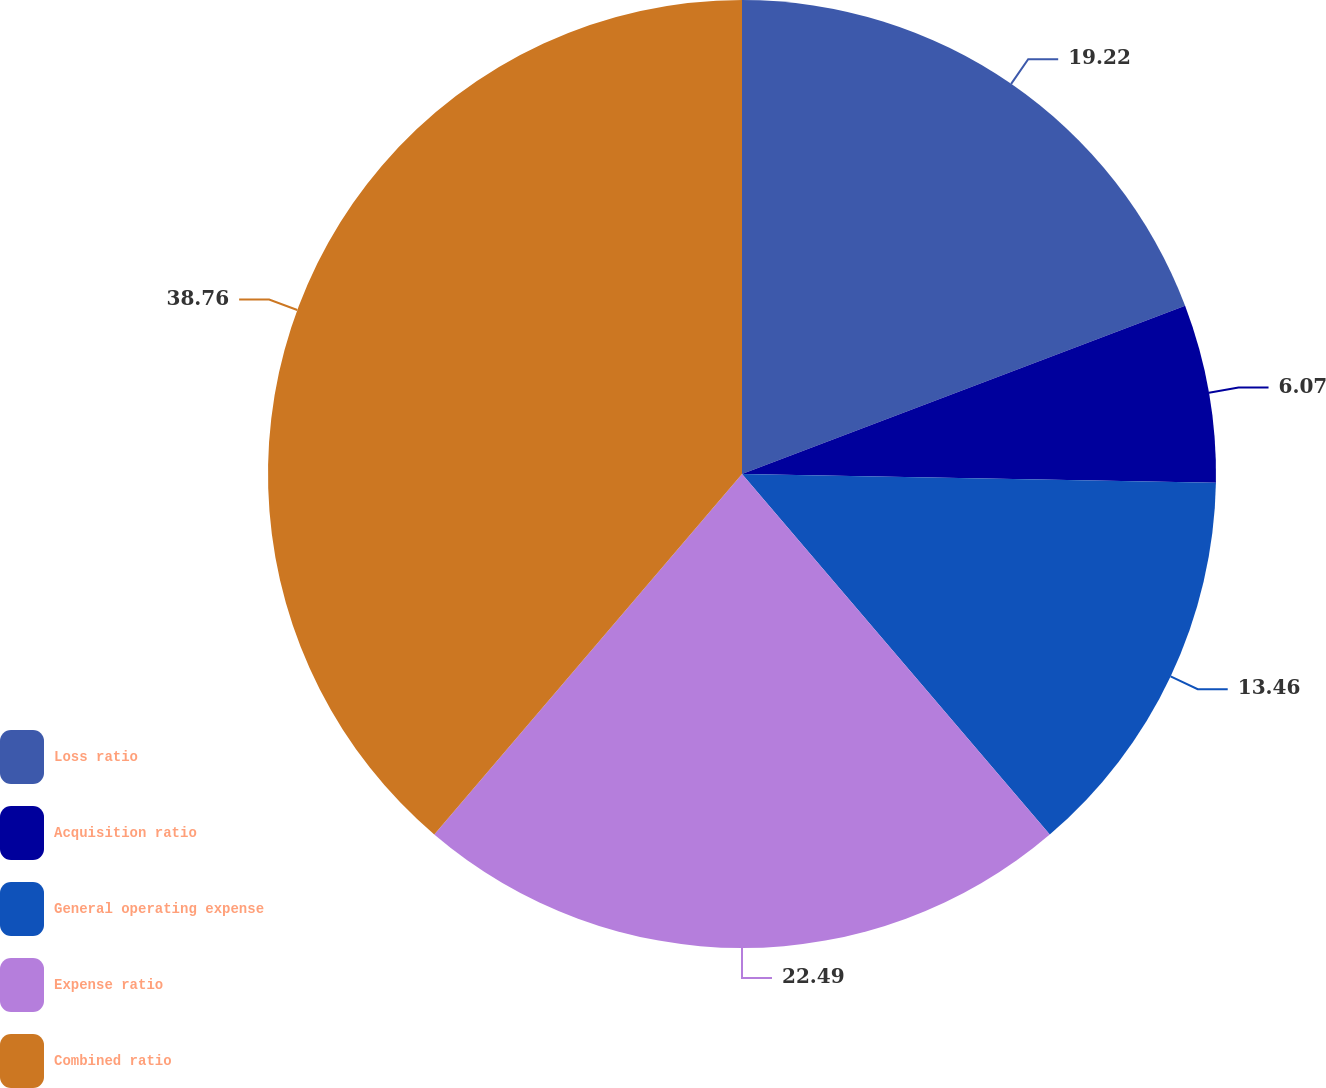Convert chart. <chart><loc_0><loc_0><loc_500><loc_500><pie_chart><fcel>Loss ratio<fcel>Acquisition ratio<fcel>General operating expense<fcel>Expense ratio<fcel>Combined ratio<nl><fcel>19.22%<fcel>6.07%<fcel>13.46%<fcel>22.49%<fcel>38.75%<nl></chart> 